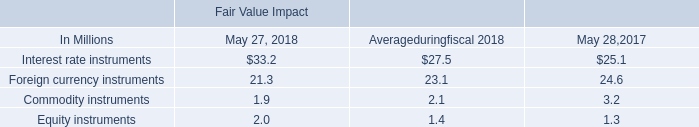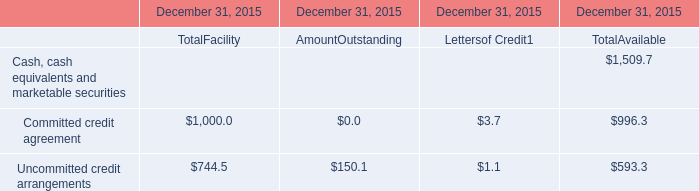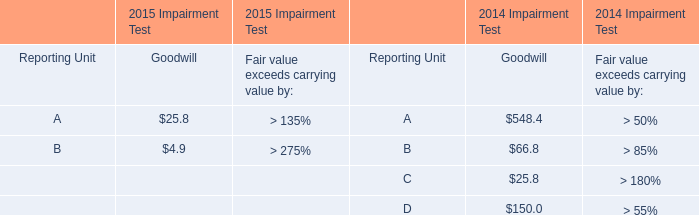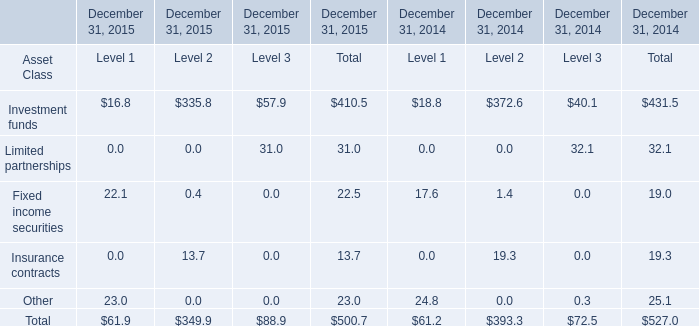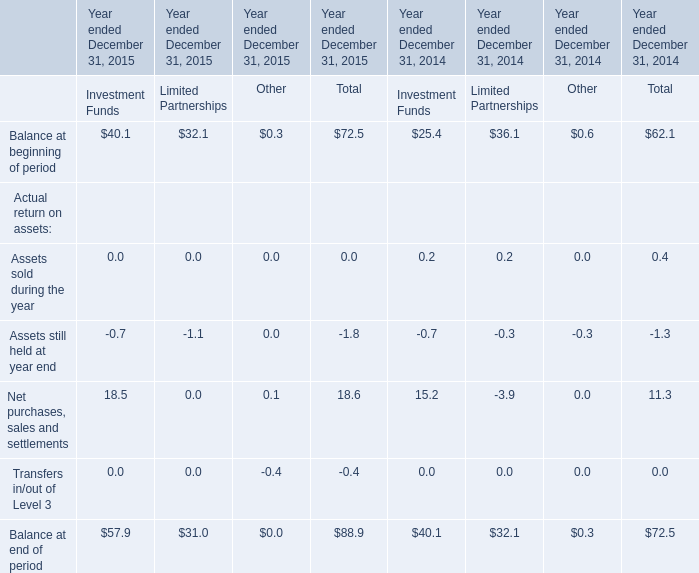What is the growing rate of Assets still held at year end in the year with the least Assets sold during the year? 
Computations: ((-1.8 + 1.3) / -1.3)
Answer: 0.38462. 